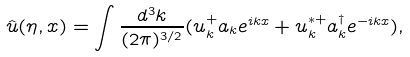Convert formula to latex. <formula><loc_0><loc_0><loc_500><loc_500>\hat { u } ( \eta , x ) = \int \frac { d ^ { 3 } k } { ( 2 \pi ) ^ { 3 / 2 } } ( u _ { k } ^ { + } a _ { k } e ^ { i k x } + u _ { k } ^ { * + } a _ { k } ^ { \dagger } e ^ { - i k x } ) ,</formula> 